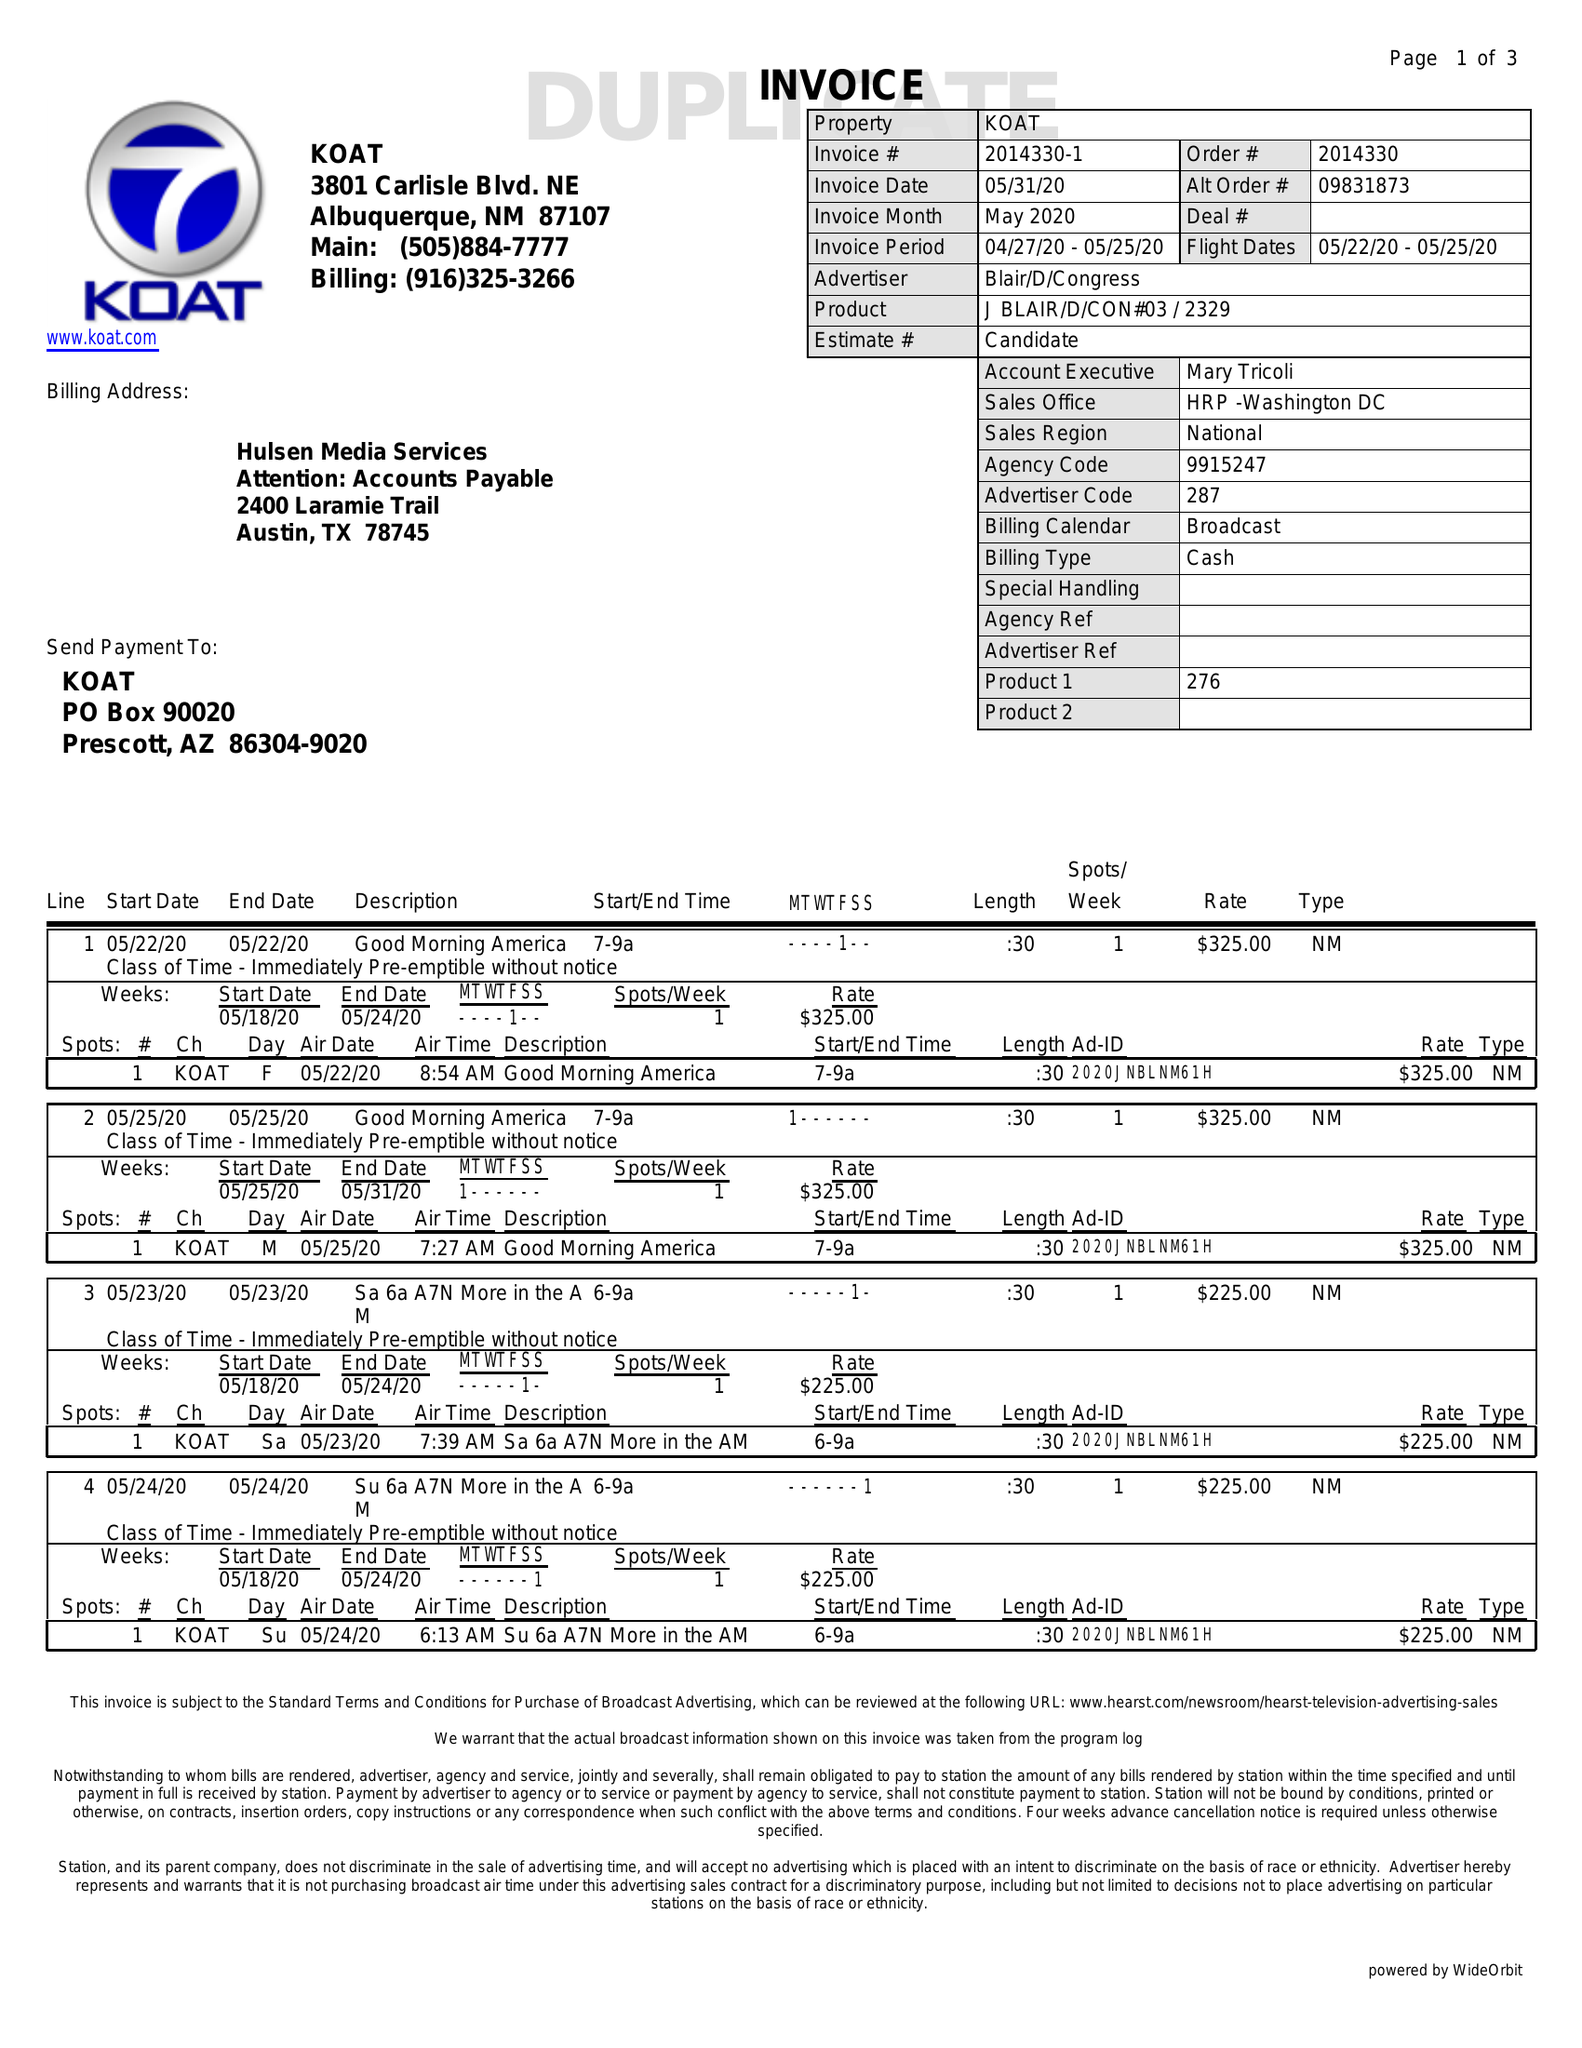What is the value for the advertiser?
Answer the question using a single word or phrase. BLAIR/D/CONGRESS 